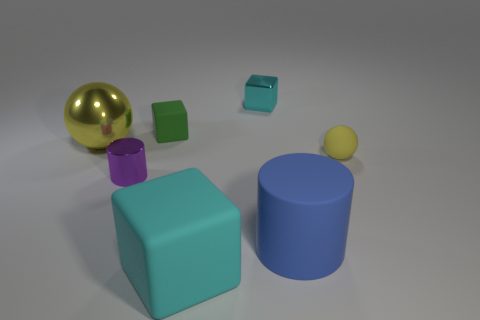Are there an equal number of matte balls that are right of the green rubber block and cyan matte things in front of the tiny yellow rubber ball?
Keep it short and to the point. Yes. How many green objects are either metal balls or tiny blocks?
Your answer should be compact. 1. How many blue metal spheres are the same size as the yellow rubber sphere?
Ensure brevity in your answer.  0. What is the color of the rubber object that is to the left of the big blue cylinder and behind the blue rubber thing?
Your answer should be very brief. Green. Are there more big rubber cubes in front of the small yellow sphere than large red cylinders?
Offer a very short reply. Yes. Are there any brown things?
Ensure brevity in your answer.  No. Do the large block and the metallic block have the same color?
Give a very brief answer. Yes. How many tiny things are gray matte spheres or matte cylinders?
Offer a very short reply. 0. Is there anything else that has the same color as the big cylinder?
Ensure brevity in your answer.  No. There is a large yellow object that is made of the same material as the tiny purple thing; what shape is it?
Your response must be concise. Sphere. 